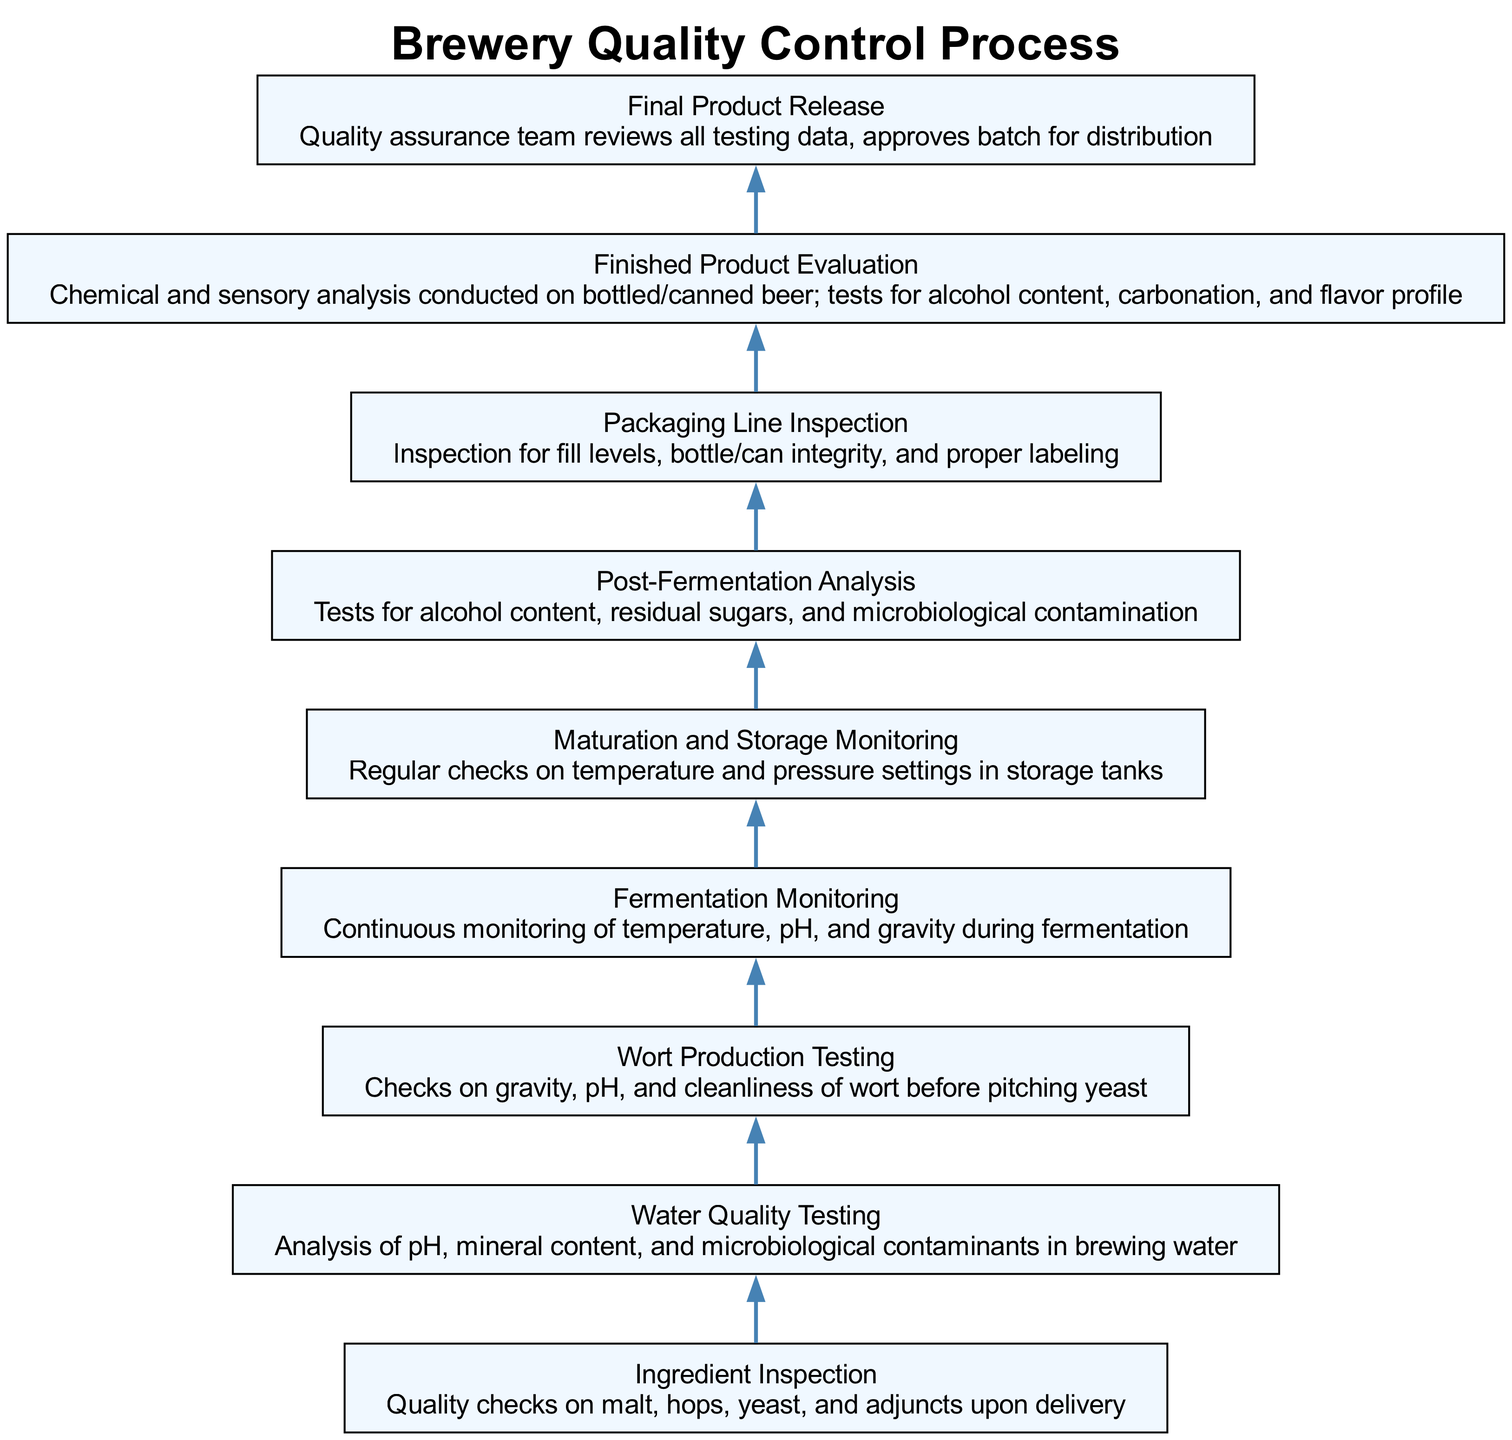What is the first step in the quality control process? The first step listed in the diagram at the bottom is "Ingredient Inspection." This is where quality checks on malt, hops, yeast, and adjuncts occur upon delivery.
Answer: Ingredient Inspection How many steps are there in the quality control process? Counting all the nodes in the diagram from the bottom to the top, there are 9 steps listed in total.
Answer: 9 What action is taken after "Finished Product Evaluation"? According to the flow, after "Finished Product Evaluation," the next step is "Final Product Release," where the quality assurance team reviews testing data and approves the batch.
Answer: Final Product Release Which step involves checks on fermentation parameters? The step that involves checks on fermentation parameters is "Fermentation Monitoring," where continuous monitoring of temperature, pH, and gravity occurs during fermentation.
Answer: Fermentation Monitoring What is tested during "Post-Fermentation Analysis"? In "Post-Fermentation Analysis," tests are conducted for alcohol content, residual sugars, and microbiological contamination, as listed next to this step.
Answer: Alcohol content, residual sugars, and microbiological contamination Which action precedes "Packaging Line Inspection"? The step prior to "Packaging Line Inspection" is "Finished Product Evaluation." This is where chemical and sensory analysis is conducted on the bottled or canned beer.
Answer: Finished Product Evaluation How does "Wort Production Testing" contribute to the quality control process? "Wort Production Testing" occurs before fermentation; it ensures the wort's gravity, pH, and cleanliness are checked before yeast is pitched, contributing to the overall quality.
Answer: Ensures gravity, pH, and cleanliness of wort What condition is monitored during "Maturation and Storage Monitoring"? During "Maturation and Storage Monitoring," the condition that is regularly checked is the temperature and pressure settings in storage tanks.
Answer: Temperature and pressure settings What is the last step in the quality control process? The last step shown at the top of the diagram is "Final Product Release," where the batch is approved for distribution.
Answer: Final Product Release 